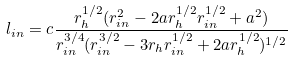<formula> <loc_0><loc_0><loc_500><loc_500>l _ { i n } = c \frac { r _ { h } ^ { 1 / 2 } ( r _ { i n } ^ { 2 } - 2 a r _ { h } ^ { 1 / 2 } r _ { i n } ^ { 1 / 2 } + a ^ { 2 } ) } { r _ { i n } ^ { 3 / 4 } ( r _ { i n } ^ { 3 / 2 } - 3 r _ { h } r _ { i n } ^ { 1 / 2 } + 2 a r _ { h } ^ { 1 / 2 } ) ^ { 1 / 2 } }</formula> 